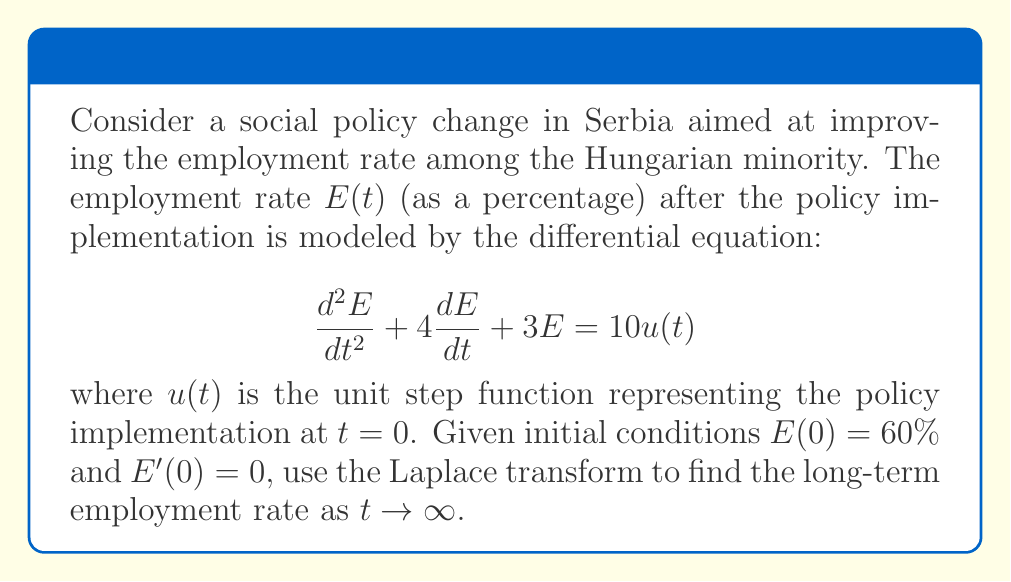What is the answer to this math problem? 1) Take the Laplace transform of both sides of the equation:
   $$\mathcal{L}\{\frac{d^2E}{dt^2} + 4\frac{dE}{dt} + 3E\} = \mathcal{L}\{10u(t)\}$$

2) Apply Laplace transform properties:
   $$s^2E(s) - sE(0) - E'(0) + 4[sE(s) - E(0)] + 3E(s) = \frac{10}{s}$$

3) Substitute initial conditions $E(0) = 60$ and $E'(0) = 0$:
   $$s^2E(s) - 60s + 4sE(s) - 240 + 3E(s) = \frac{10}{s}$$

4) Collect terms with $E(s)$:
   $$(s^2 + 4s + 3)E(s) = \frac{10}{s} + 60s + 240$$

5) Solve for $E(s)$:
   $$E(s) = \frac{10/s + 60s + 240}{s^2 + 4s + 3} = \frac{10 + 60s^2 + 240s}{s(s^2 + 4s + 3)}$$

6) Decompose into partial fractions:
   $$E(s) = \frac{A}{s} + \frac{B}{s+1} + \frac{C}{s+3}$$

7) Solve for $A$, $B$, and $C$:
   $$A = \lim_{s \to 0} sE(s) = \frac{10}{3} \approx 3.33$$
   $$B = \lim_{s \to -1} (s+1)E(s) = -\frac{70}{4} = -17.5$$
   $$C = \lim_{s \to -3} (s+3)E(s) = \frac{790}{12} \approx 65.83$$

8) Take the inverse Laplace transform:
   $$E(t) = 3.33 - 17.5e^{-t} + 65.83e^{-3t}$$

9) Calculate the limit as $t \to \infty$:
   $$\lim_{t \to \infty} E(t) = 3.33$$
Answer: $3.33\%$ 